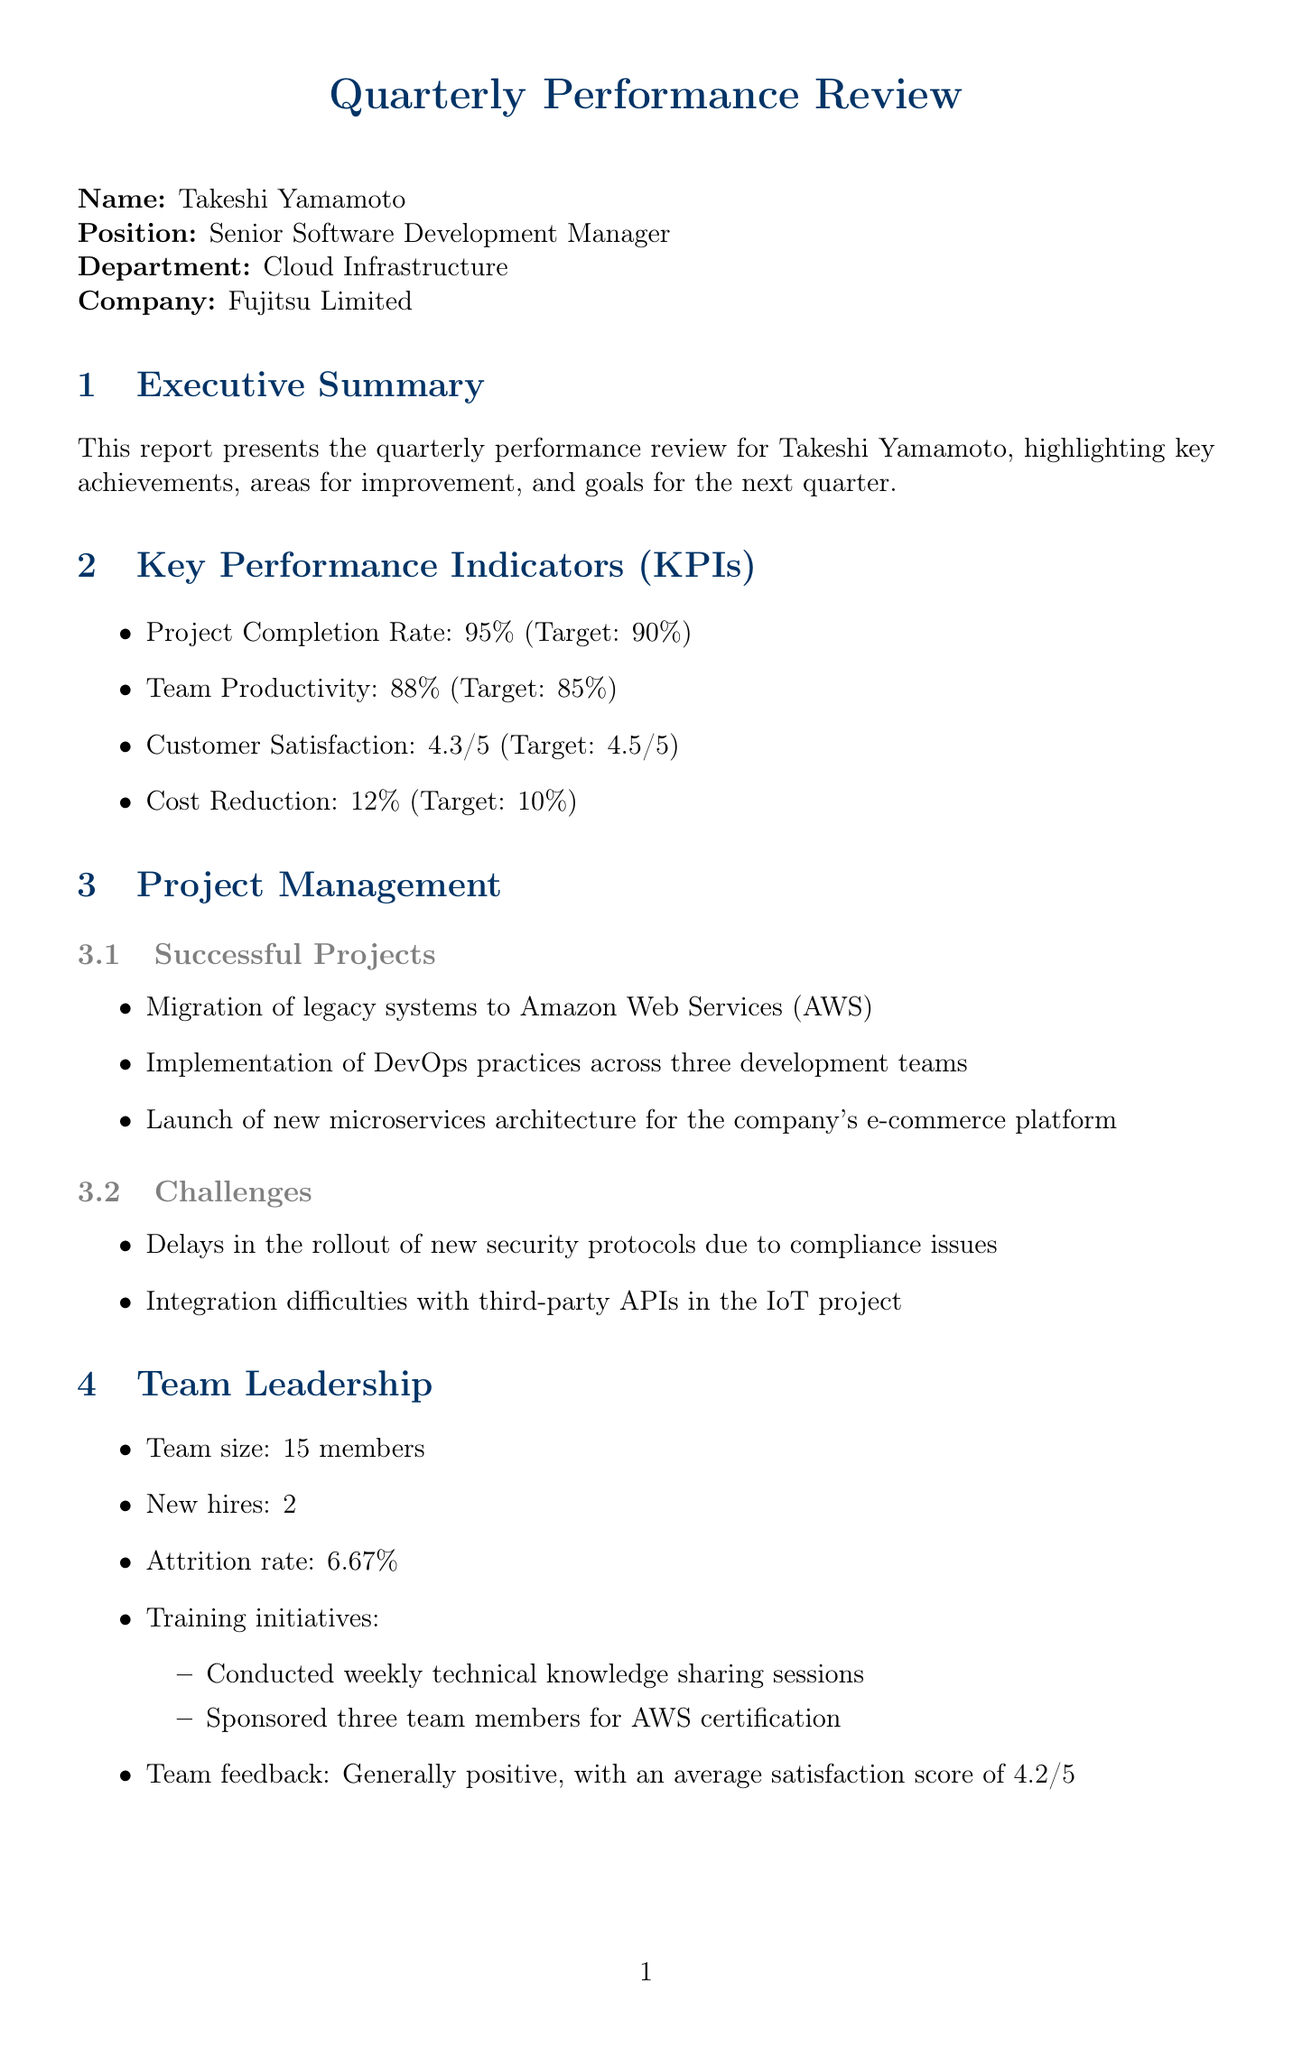What is the name of the manager? The name of the manager is mentioned in the "manager_info" section.
Answer: Takeshi Yamamoto What was the actual project completion rate? The actual project completion rate is specified in the "Key Performance Indicators (KPIs)" section.
Answer: 95% How many training initiatives were conducted? The number of training initiatives is listed under the "Team Leadership" section.
Answer: 2 What was the average team satisfaction score? The average team satisfaction score is found in the "Team Leadership" section.
Answer: 4.2/5 What is one area for improvement related to customer satisfaction? Areas for improvement regarding customer satisfaction are detailed in the "Areas for Improvement" section.
Answer: Enhance incident response time What was the goal for the next quarter related to project completion? The goal for the next quarter can be found in the "Goals for Next Quarter" section.
Answer: Achieve 100% project completion rate What is one strength mentioned in the technical skills? Strengths in technical skills are outlined in the "Technical Skills" section.
Answer: Expert in Java and Python programming What is the current attrition rate of the team? The attrition rate is noted in the "Team Leadership" section.
Answer: 6.67% How many successful projects were mentioned? The number of successful projects is enumerated in the "Project Management" section.
Answer: 3 